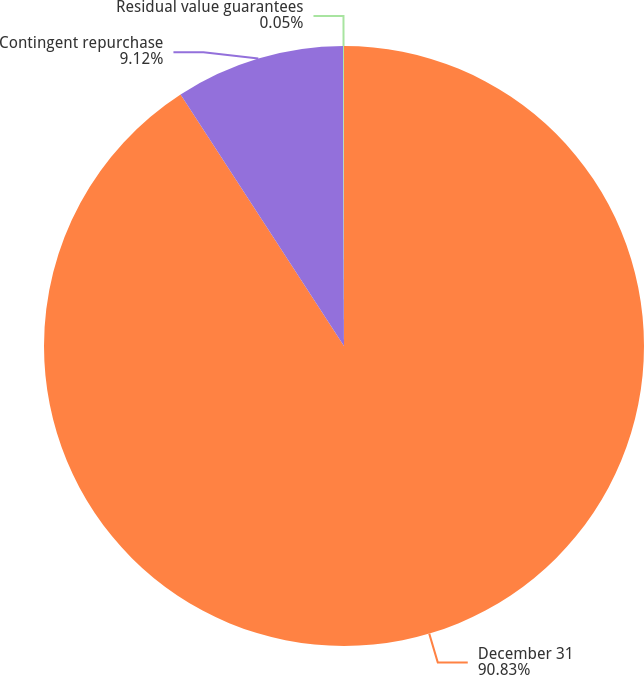<chart> <loc_0><loc_0><loc_500><loc_500><pie_chart><fcel>December 31<fcel>Contingent repurchase<fcel>Residual value guarantees<nl><fcel>90.83%<fcel>9.12%<fcel>0.05%<nl></chart> 